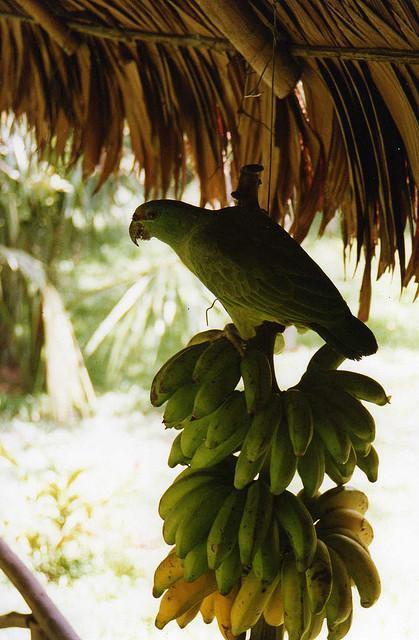Evaluate: Does the caption "The banana is under the bird." match the image?
Answer yes or no. Yes. 